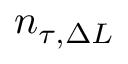<formula> <loc_0><loc_0><loc_500><loc_500>n _ { \tau , \Delta L }</formula> 